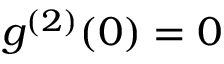<formula> <loc_0><loc_0><loc_500><loc_500>g ^ { ( 2 ) } ( 0 ) = 0</formula> 